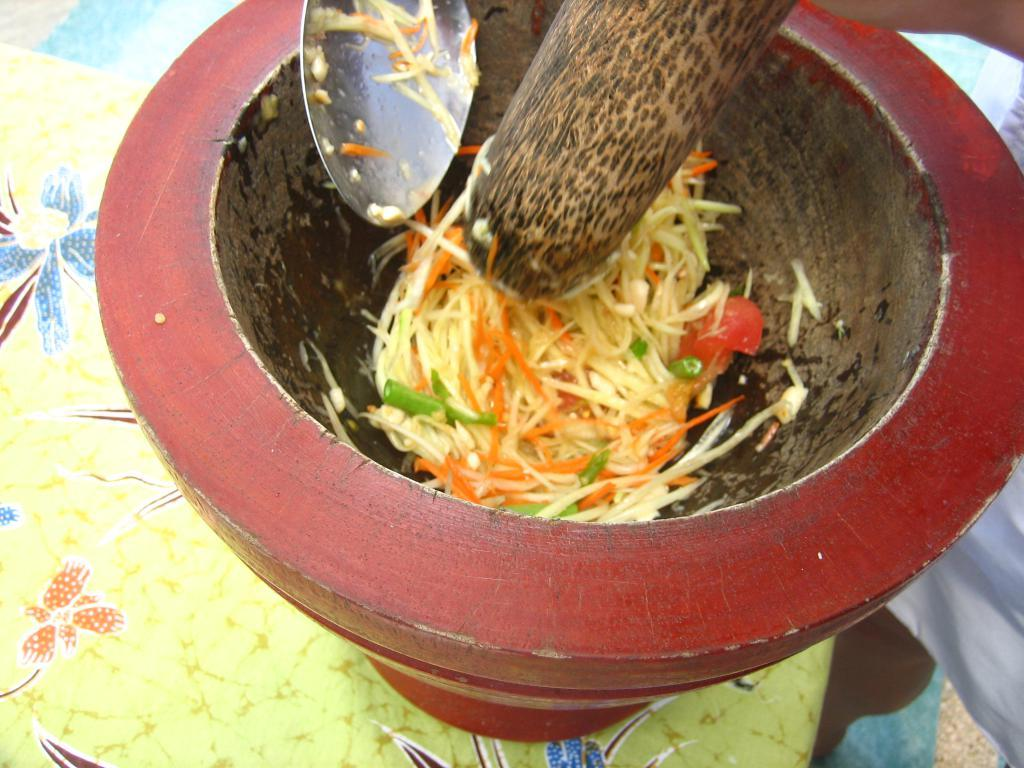What type of food is in the bowl in the image? There is a salad in a bowl in the image. What utensil is in the bowl with the salad? There is a spoon in the bowl with the salad. What is the wooden object in the bowl with the salad? There is a wooden rock in the bowl with the salad. Where is the bowl with the salad located? The bowl with the salad is on a table. Can you describe the person visible on the right side of the image? There is a person visible on the right side of the image, but their description is not provided in the facts. What type of credit card is the person using to pay for the salad in the image? There is no information about a credit card or payment in the image. 